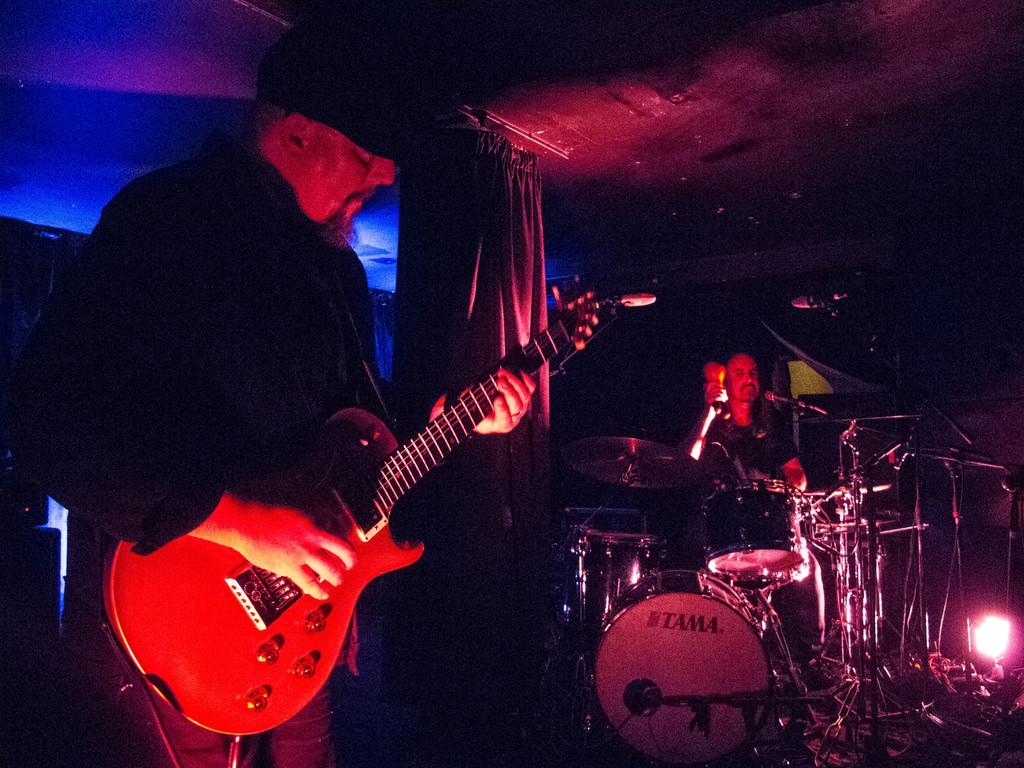What is the person on the left side of the image doing? The person on the left is playing a guitar. What is the person on the right side of the image doing? The person on the right is playing musical instruments. How many people are playing musical instruments in the image? Both people in the image are playing musical instruments. Can you see a rose in the middle of the image? There is no rose present in the image. What arithmetic problem is being solved by the person on the right side of the image? There is no arithmetic problem being solved in the image; both people are playing musical instruments. 